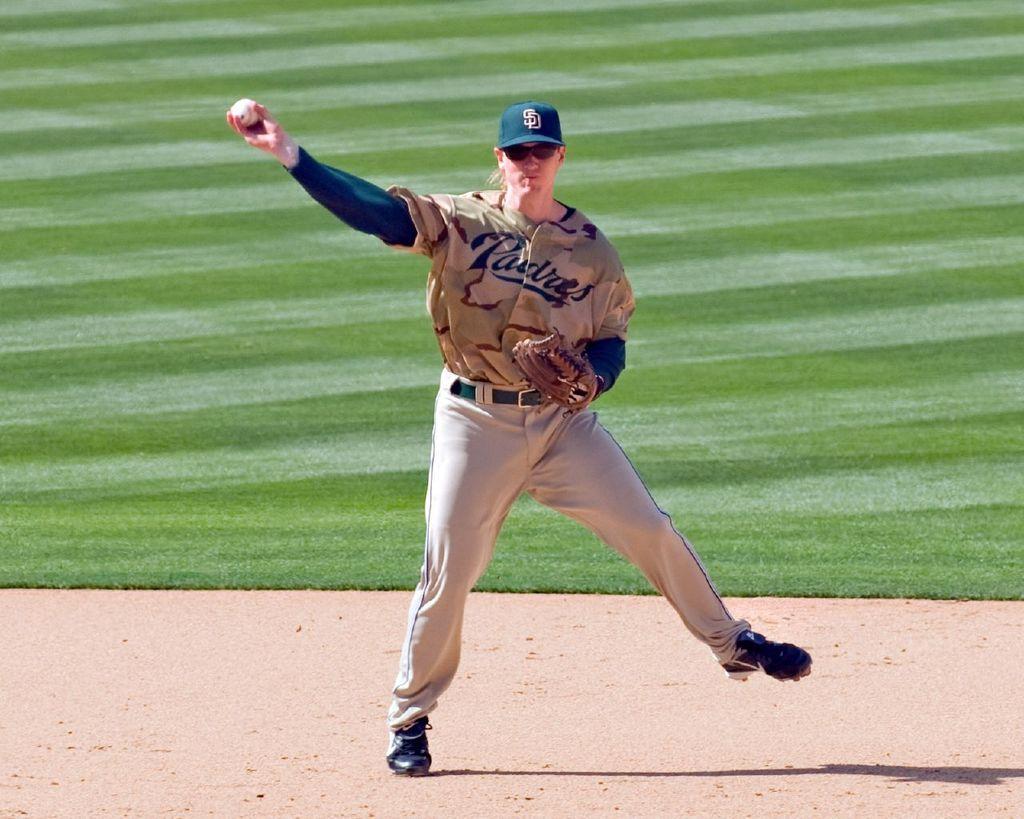How would you summarize this image in a sentence or two? In this image I can see a woman in the middle, wearing a glove and cap and holding a ball. 